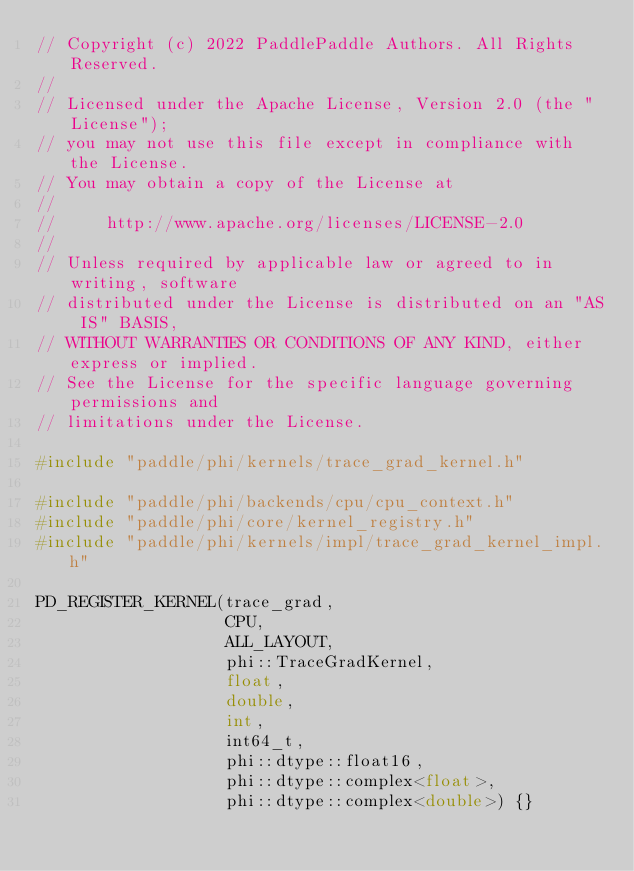Convert code to text. <code><loc_0><loc_0><loc_500><loc_500><_C++_>// Copyright (c) 2022 PaddlePaddle Authors. All Rights Reserved.
//
// Licensed under the Apache License, Version 2.0 (the "License");
// you may not use this file except in compliance with the License.
// You may obtain a copy of the License at
//
//     http://www.apache.org/licenses/LICENSE-2.0
//
// Unless required by applicable law or agreed to in writing, software
// distributed under the License is distributed on an "AS IS" BASIS,
// WITHOUT WARRANTIES OR CONDITIONS OF ANY KIND, either express or implied.
// See the License for the specific language governing permissions and
// limitations under the License.

#include "paddle/phi/kernels/trace_grad_kernel.h"

#include "paddle/phi/backends/cpu/cpu_context.h"
#include "paddle/phi/core/kernel_registry.h"
#include "paddle/phi/kernels/impl/trace_grad_kernel_impl.h"

PD_REGISTER_KERNEL(trace_grad,
                   CPU,
                   ALL_LAYOUT,
                   phi::TraceGradKernel,
                   float,
                   double,
                   int,
                   int64_t,
                   phi::dtype::float16,
                   phi::dtype::complex<float>,
                   phi::dtype::complex<double>) {}
</code> 